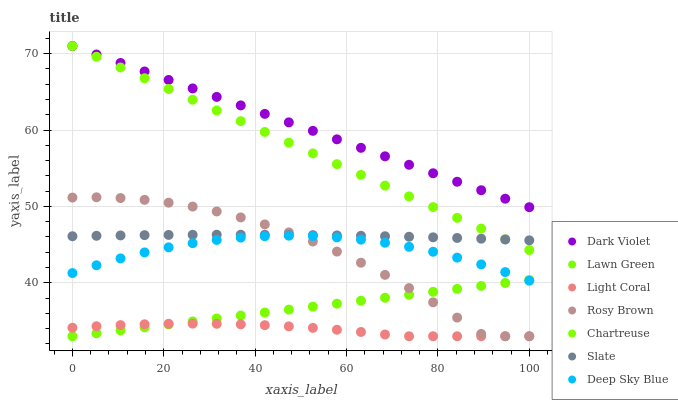Does Light Coral have the minimum area under the curve?
Answer yes or no. Yes. Does Dark Violet have the maximum area under the curve?
Answer yes or no. Yes. Does Slate have the minimum area under the curve?
Answer yes or no. No. Does Slate have the maximum area under the curve?
Answer yes or no. No. Is Lawn Green the smoothest?
Answer yes or no. Yes. Is Rosy Brown the roughest?
Answer yes or no. Yes. Is Slate the smoothest?
Answer yes or no. No. Is Slate the roughest?
Answer yes or no. No. Does Lawn Green have the lowest value?
Answer yes or no. Yes. Does Slate have the lowest value?
Answer yes or no. No. Does Chartreuse have the highest value?
Answer yes or no. Yes. Does Slate have the highest value?
Answer yes or no. No. Is Light Coral less than Slate?
Answer yes or no. Yes. Is Deep Sky Blue greater than Light Coral?
Answer yes or no. Yes. Does Deep Sky Blue intersect Lawn Green?
Answer yes or no. Yes. Is Deep Sky Blue less than Lawn Green?
Answer yes or no. No. Is Deep Sky Blue greater than Lawn Green?
Answer yes or no. No. Does Light Coral intersect Slate?
Answer yes or no. No. 